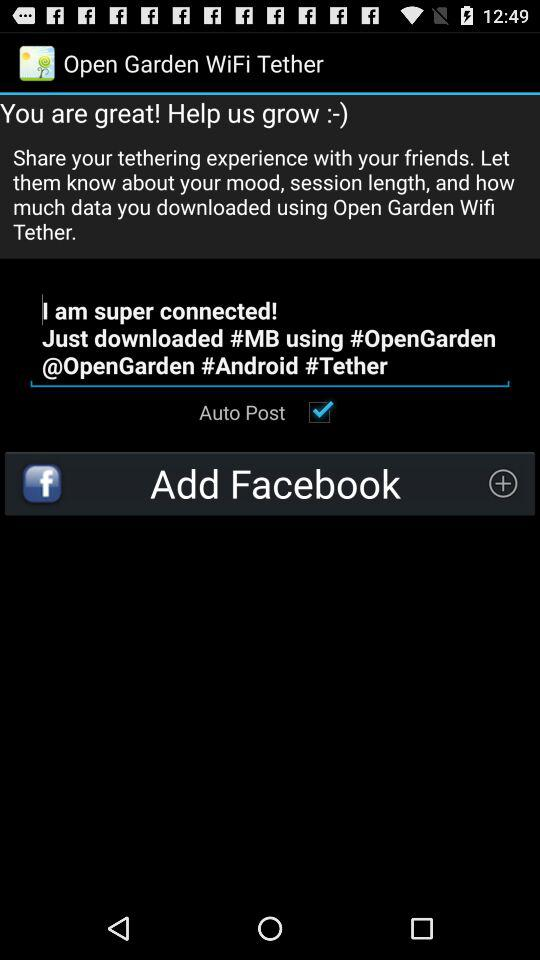What option is selected on the screen? The option selected on the screen is "Auto Post". 